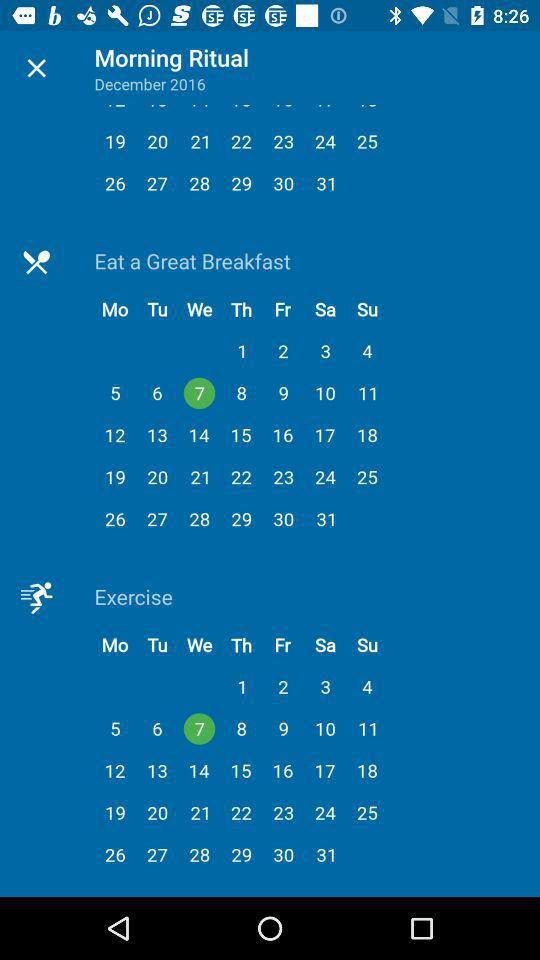What date is selected for "Eat a Great Breakfast"? The date is Wednesday, December 7, 2016. 